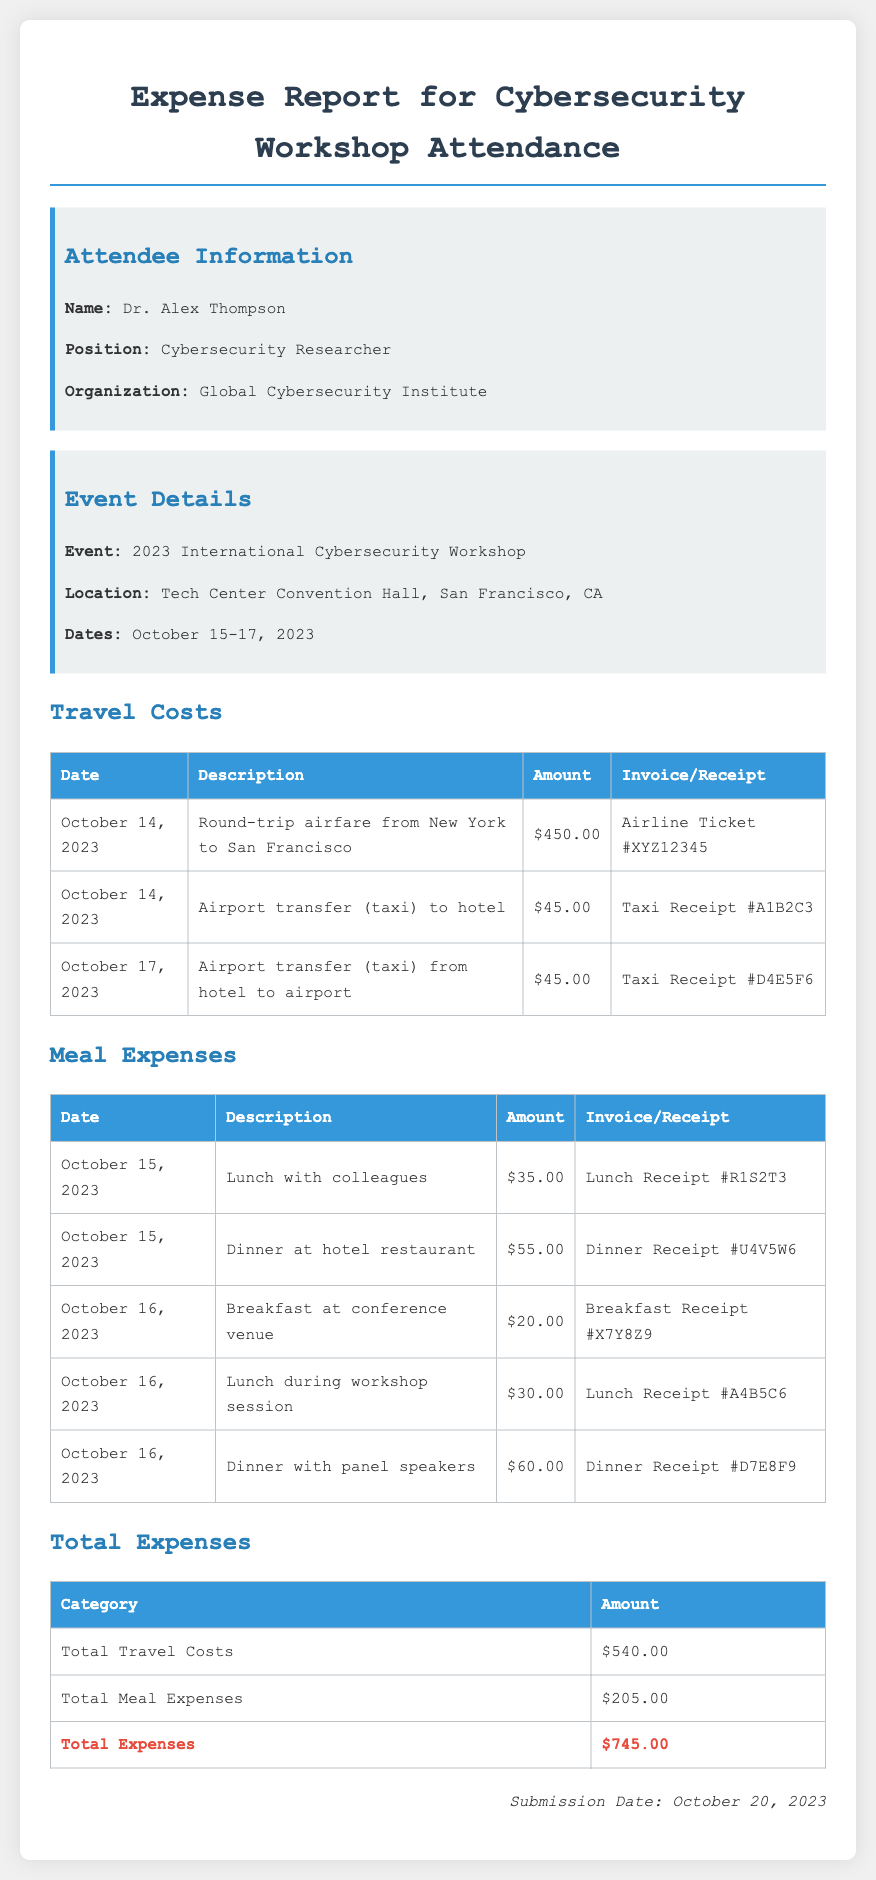What is the name of the attendee? The name of the attendee is provided in the attendee information section of the document.
Answer: Dr. Alex Thompson What is the total amount for travel costs? The total amount for travel costs is given in the total expenses table under the travel costs category.
Answer: $540.00 What city did the workshop take place in? The event location is specified in the event details section of the document.
Answer: San Francisco, CA How many days did the workshop last? The workshop dates indicate the range of days it occupied, which can be calculated.
Answer: 3 days What is the date of submission for the expense report? The submission date is located at the bottom of the document.
Answer: October 20, 2023 What was the cost of the dinner at the hotel restaurant? The specific amount for the dinner is listed in the meal expenses table.
Answer: $55.00 What is the total amount for meal expenses? The total amount for meal expenses is provided in the total expenses table under meal expenses.
Answer: $205.00 What invoice number is associated with the first taxi receipt? The first taxi receipt's invoice number is specified in the travel costs section.
Answer: Taxi Receipt #A1B2C3 How much was spent on lunch with colleagues? The amount spent on lunch with colleagues is detailed in the meal expenses table.
Answer: $35.00 